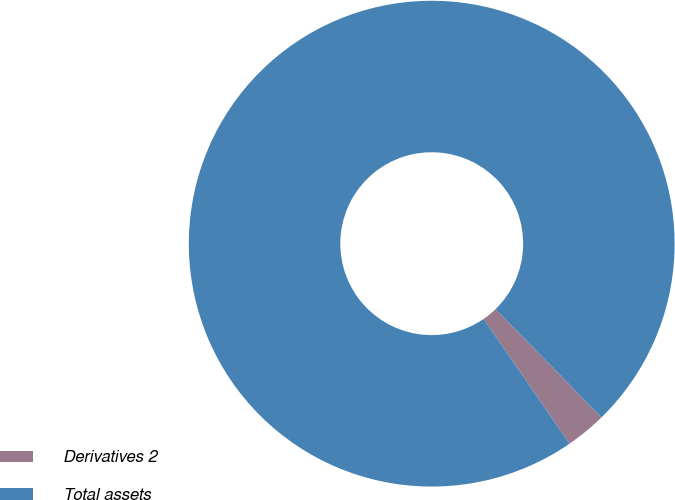Convert chart. <chart><loc_0><loc_0><loc_500><loc_500><pie_chart><fcel>Derivatives 2<fcel>Total assets<nl><fcel>2.71%<fcel>97.29%<nl></chart> 